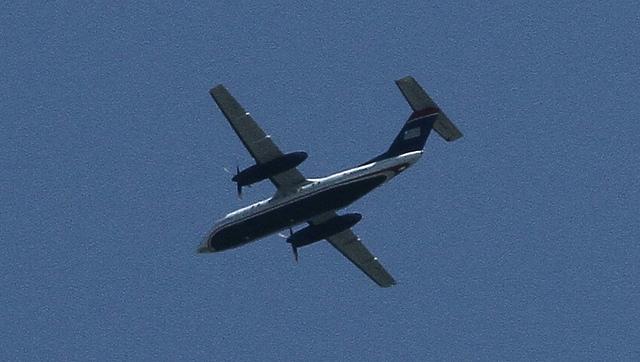What is in the sky?
Write a very short answer. Plane. What direction is the plane flying?
Answer briefly. West. What color is the sky?
Be succinct. Blue. Is the airplane on the ground?
Short answer required. No. How many propeller vehicles?
Give a very brief answer. 1. 